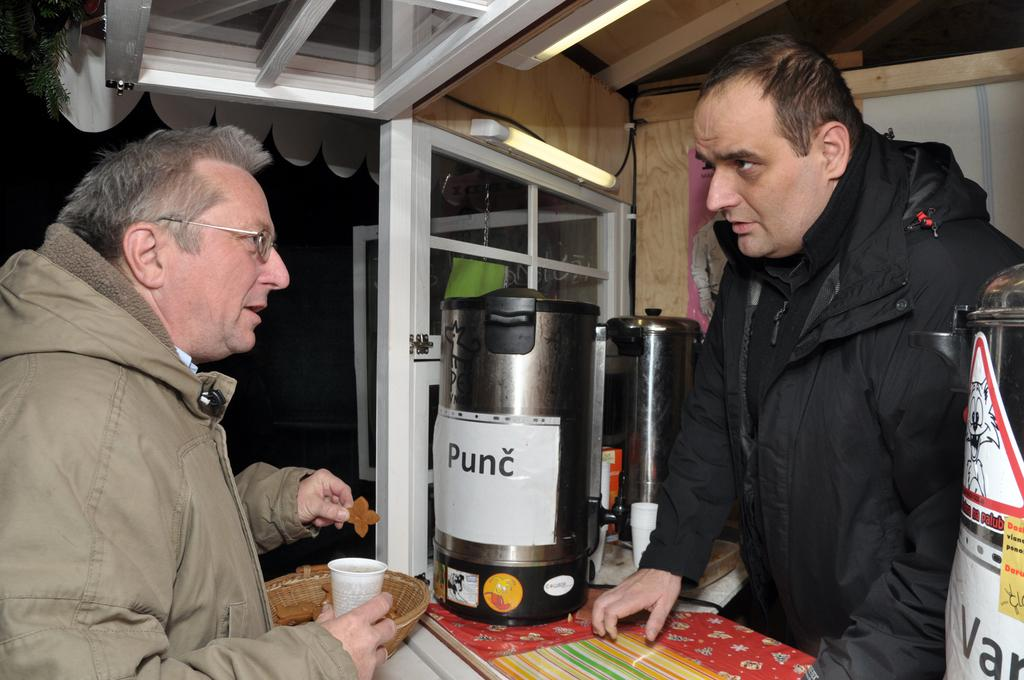<image>
Give a short and clear explanation of the subsequent image. Two men stand on opposite sides of a counter with a beverage dispenser labeled "Punc" sitting on top. 